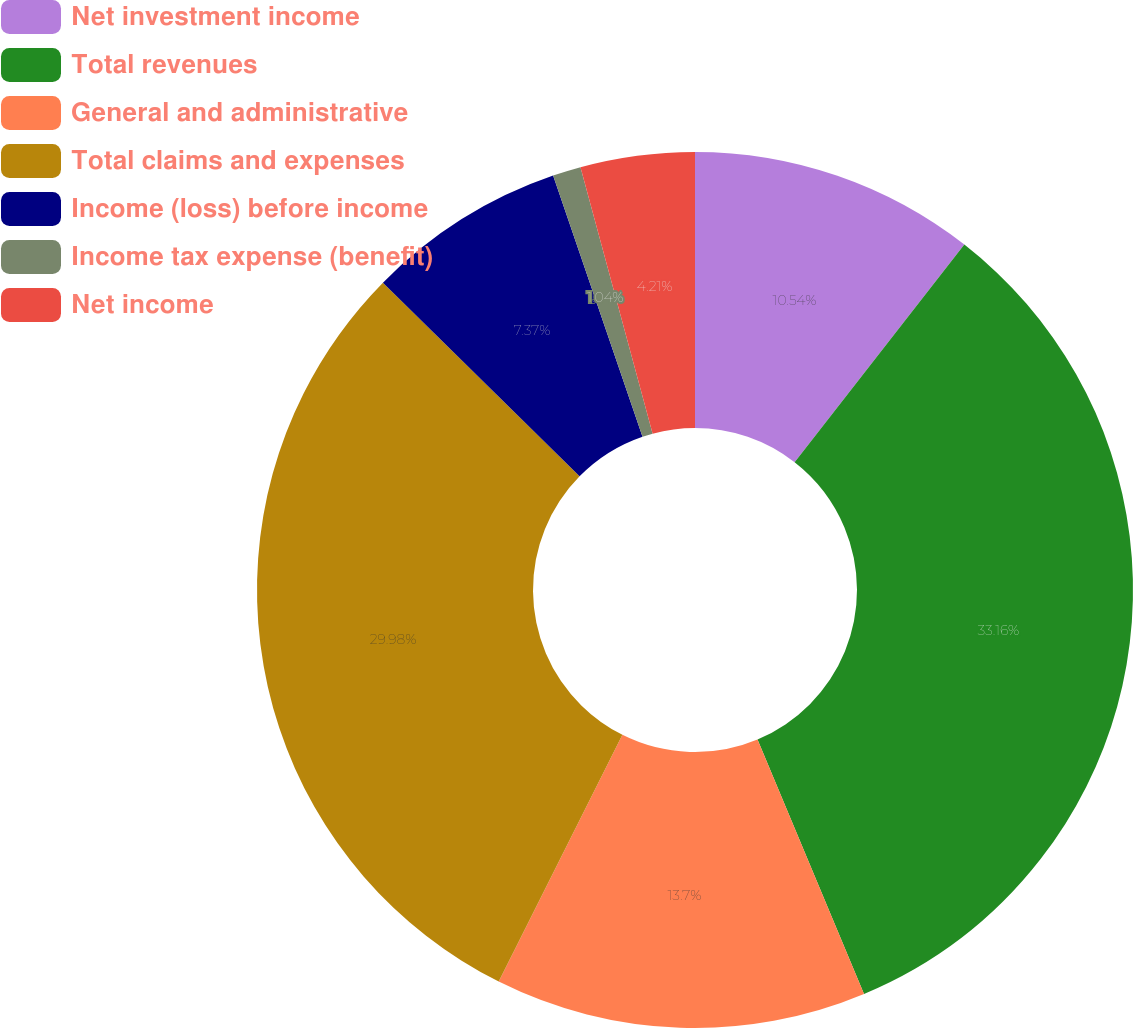Convert chart to OTSL. <chart><loc_0><loc_0><loc_500><loc_500><pie_chart><fcel>Net investment income<fcel>Total revenues<fcel>General and administrative<fcel>Total claims and expenses<fcel>Income (loss) before income<fcel>Income tax expense (benefit)<fcel>Net income<nl><fcel>10.54%<fcel>33.15%<fcel>13.7%<fcel>29.98%<fcel>7.37%<fcel>1.04%<fcel>4.21%<nl></chart> 